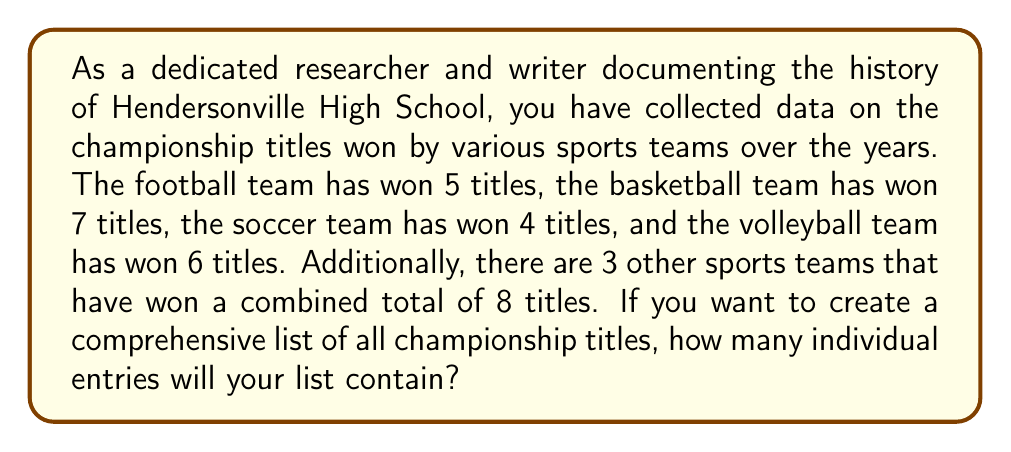Help me with this question. To solve this problem, we need to sum up all the championship titles won by the different sports teams. Let's break it down step by step:

1. Football team titles: 5
2. Basketball team titles: 7
3. Soccer team titles: 4
4. Volleyball team titles: 6
5. Other sports teams' combined titles: 8

Now, we can use the addition principle to find the total number of titles:

$$ \text{Total titles} = 5 + 7 + 4 + 6 + 8 $$

Calculating this sum:

$$ \text{Total titles} = 30 $$

Therefore, a comprehensive list of all championship titles won by Hendersonville High School sports teams would contain 30 individual entries.
Answer: $30$ championship titles 